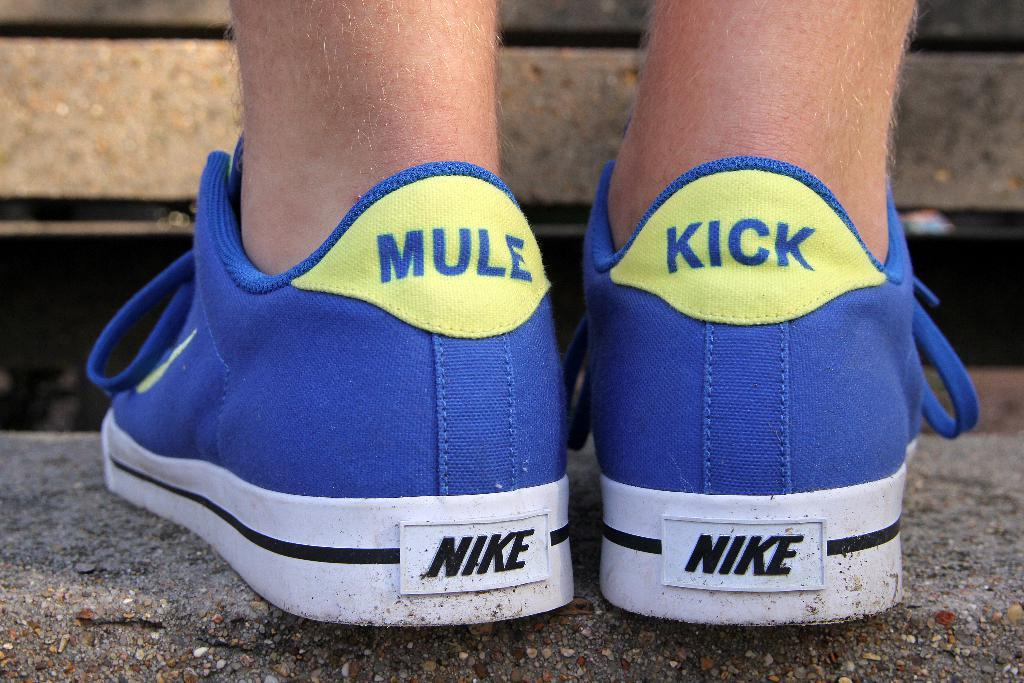<image>
Write a terse but informative summary of the picture. A pair of blue tennis shows that say Mule Kick on the heel. 